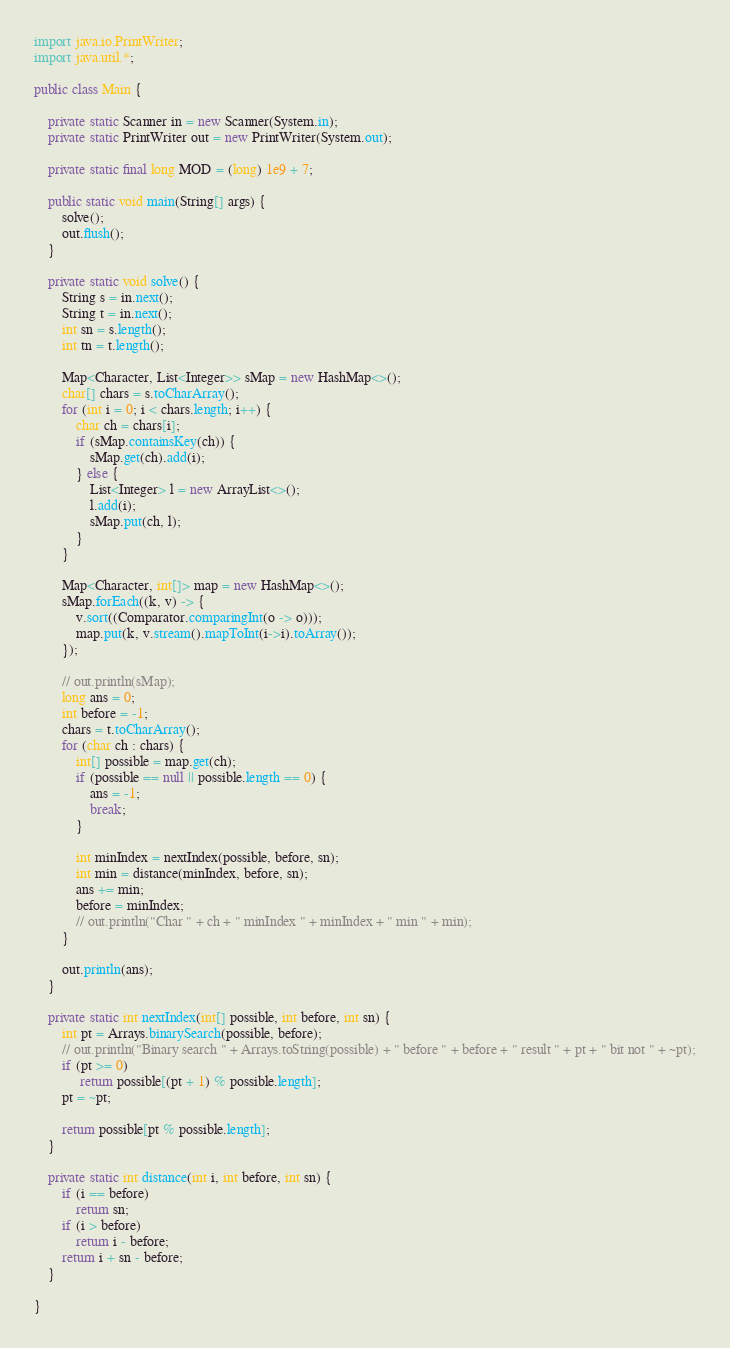Convert code to text. <code><loc_0><loc_0><loc_500><loc_500><_Java_>import java.io.PrintWriter;
import java.util.*;

public class Main {

    private static Scanner in = new Scanner(System.in);
    private static PrintWriter out = new PrintWriter(System.out);

    private static final long MOD = (long) 1e9 + 7;

    public static void main(String[] args) {
        solve();
        out.flush();
    }

    private static void solve() {
        String s = in.next();
        String t = in.next();
        int sn = s.length();
        int tn = t.length();

        Map<Character, List<Integer>> sMap = new HashMap<>();
        char[] chars = s.toCharArray();
        for (int i = 0; i < chars.length; i++) {
            char ch = chars[i];
            if (sMap.containsKey(ch)) {
                sMap.get(ch).add(i);
            } else {
                List<Integer> l = new ArrayList<>();
                l.add(i);
                sMap.put(ch, l);
            }
        }

        Map<Character, int[]> map = new HashMap<>();
        sMap.forEach((k, v) -> {
            v.sort((Comparator.comparingInt(o -> o)));
            map.put(k, v.stream().mapToInt(i->i).toArray());
        });

        // out.println(sMap);
        long ans = 0;
        int before = -1;
        chars = t.toCharArray();
        for (char ch : chars) {
            int[] possible = map.get(ch);
            if (possible == null || possible.length == 0) {
                ans = -1;
                break;
            }

            int minIndex = nextIndex(possible, before, sn);
            int min = distance(minIndex, before, sn);
            ans += min;
            before = minIndex;
            // out.println("Char " + ch + " minIndex " + minIndex + " min " + min);
        }

        out.println(ans);
    }

    private static int nextIndex(int[] possible, int before, int sn) {
        int pt = Arrays.binarySearch(possible, before);
        // out.println("Binary search " + Arrays.toString(possible) + " before " + before + " result " + pt + " bit not " + ~pt);
        if (pt >= 0)
             return possible[(pt + 1) % possible.length];
        pt = ~pt;

        return possible[pt % possible.length];
    }

    private static int distance(int i, int before, int sn) {
        if (i == before)
            return sn;
        if (i > before)
            return i - before;
        return i + sn - before;
    }

}
</code> 